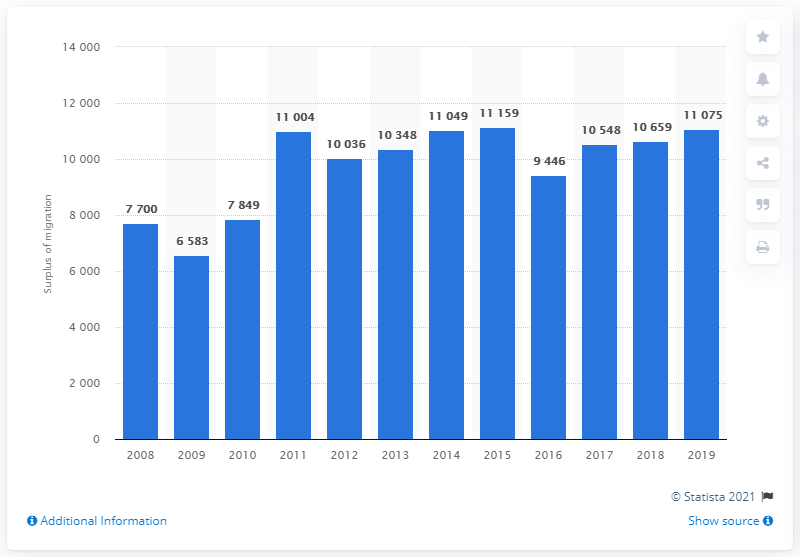Specify some key components in this picture. In the year 2015, Luxembourg's net migration reached its peak. 